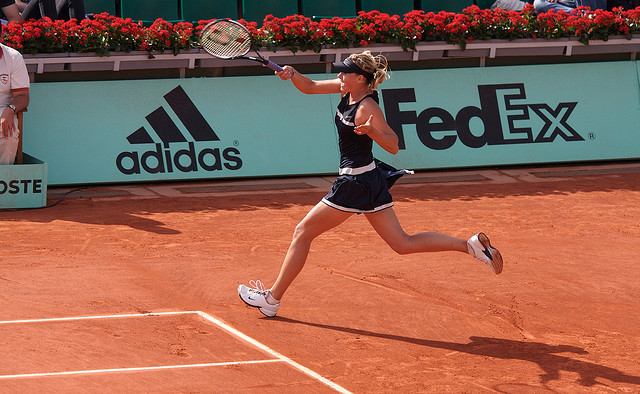Please transcribe the text information in this image. Adidas&#174; FedEx OSTE 